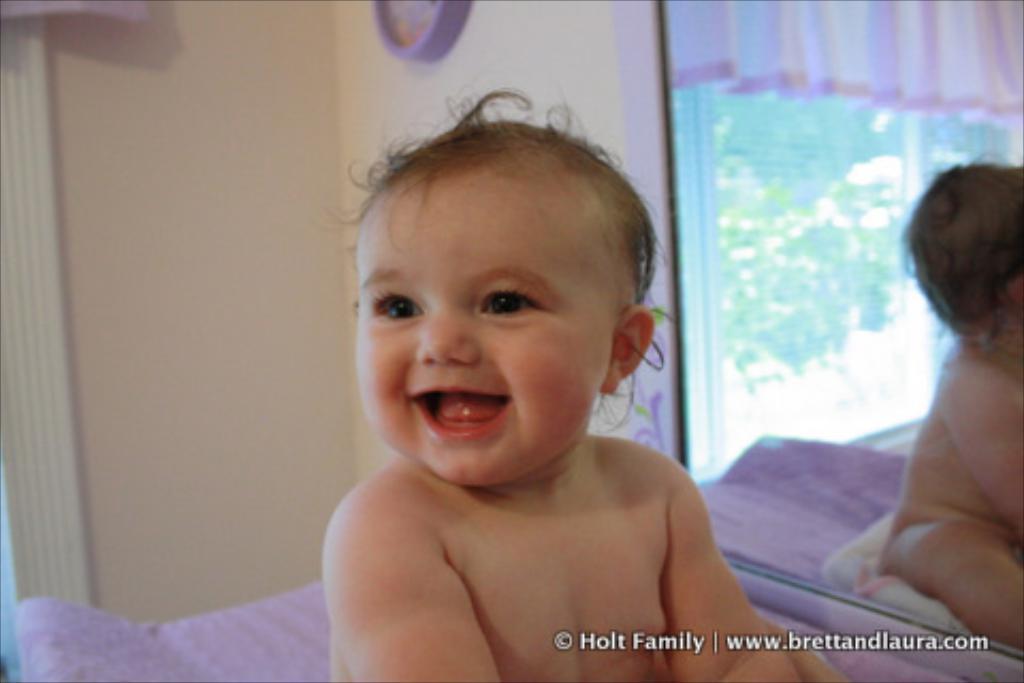Describe this image in one or two sentences. In the picture I can see a child is sitting on the violet color surface. In the background, I can see the wall and I can see the mirror in which we can see the reflection of the curtains and glass windows through which I can see trees. Here I can see the watermark at the bottom of the image. 